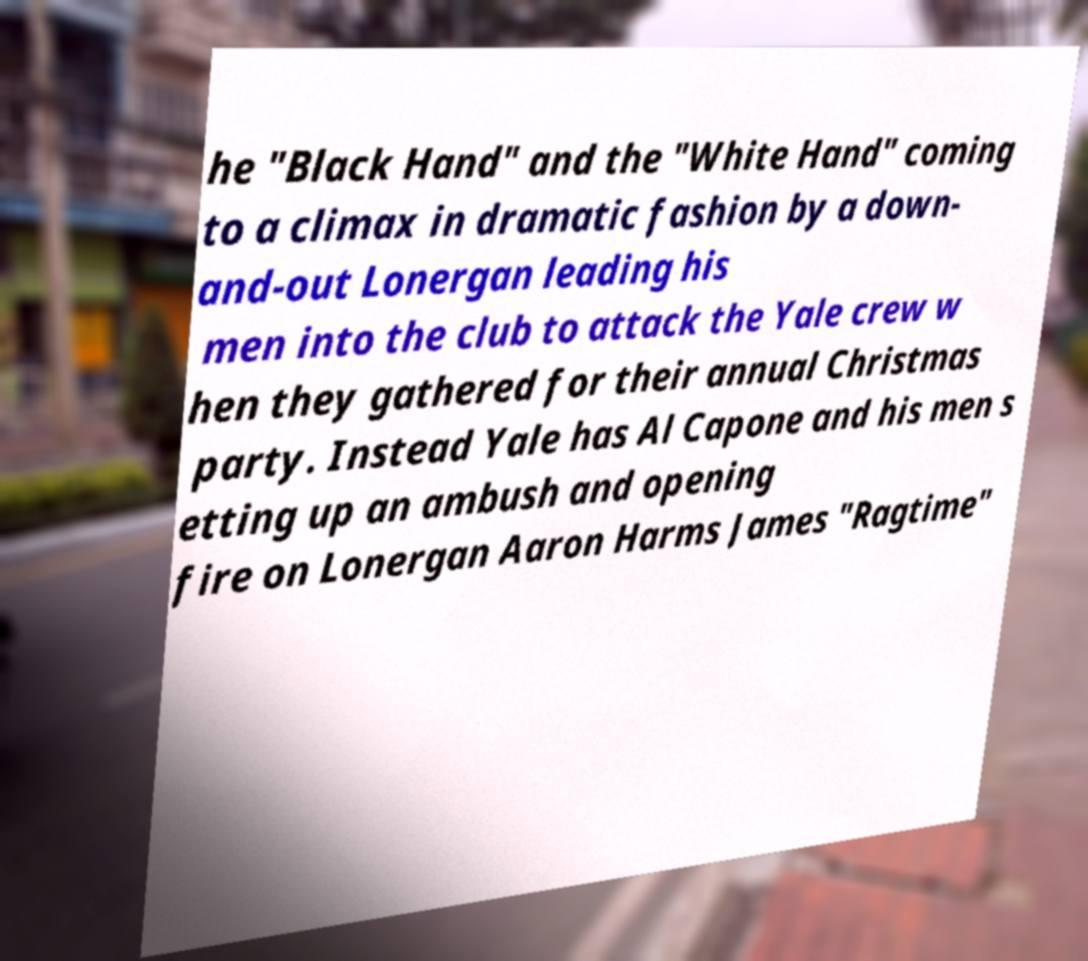Could you extract and type out the text from this image? he "Black Hand" and the "White Hand" coming to a climax in dramatic fashion by a down- and-out Lonergan leading his men into the club to attack the Yale crew w hen they gathered for their annual Christmas party. Instead Yale has Al Capone and his men s etting up an ambush and opening fire on Lonergan Aaron Harms James "Ragtime" 